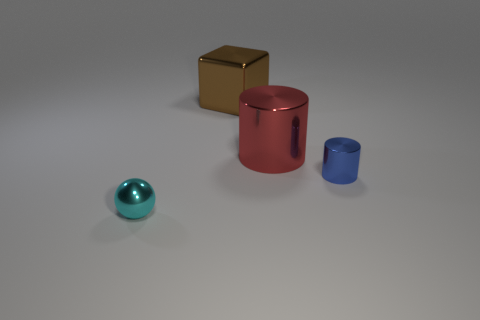Imagine these are part of an art installation. What could be the theme? As part of an art installation, the theme could be 'The Geometry of Space' where each object represents the diversity of geometric shapes and how they occupy space. 